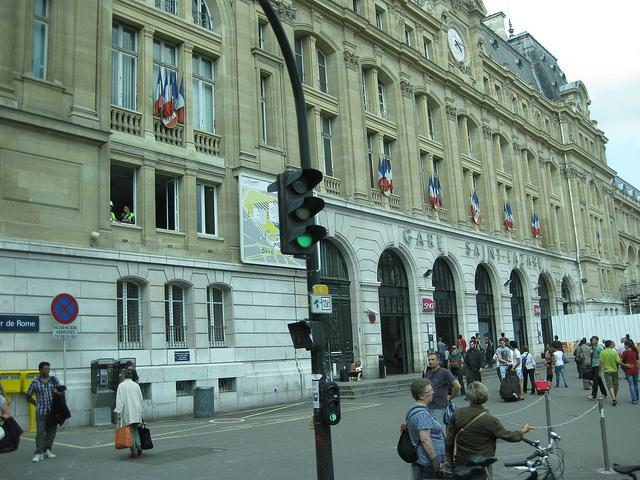What actress was born in this country? Please explain your reasoning. adele haenel. The actress is adele. 